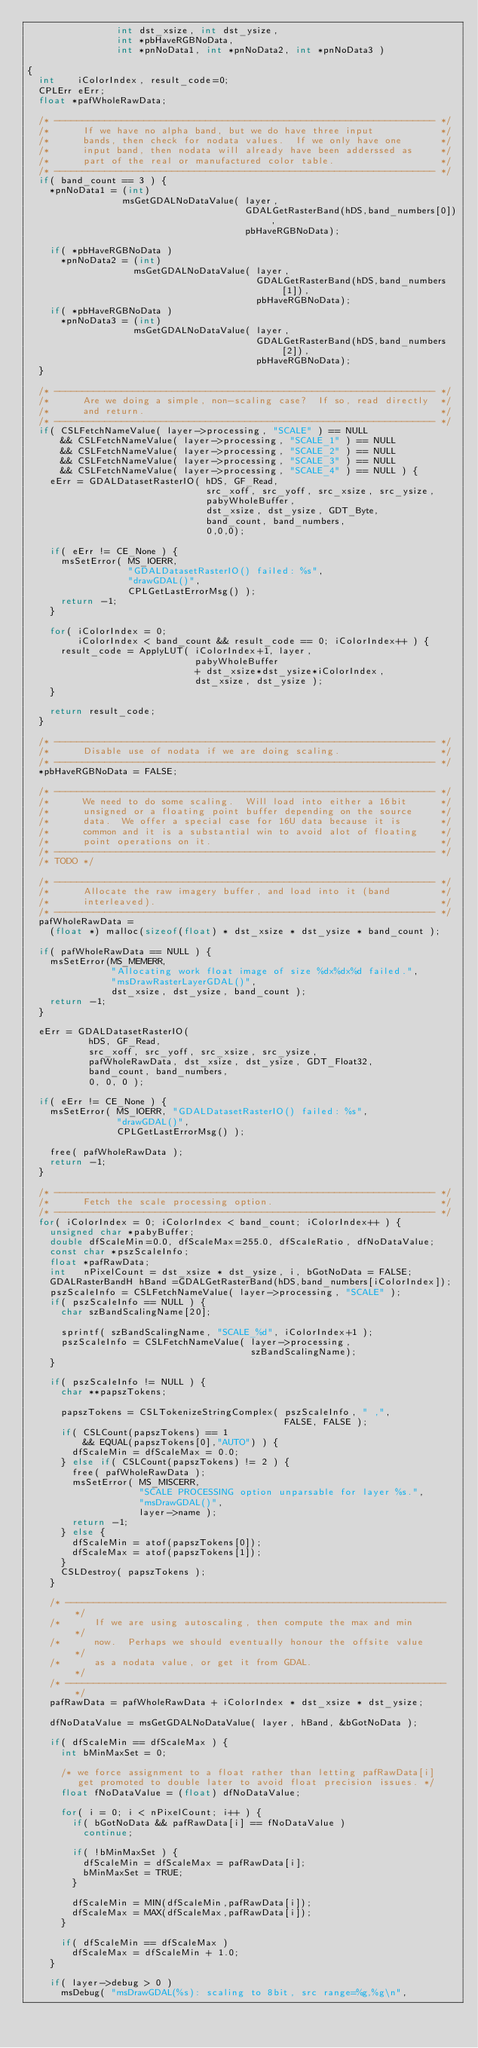Convert code to text. <code><loc_0><loc_0><loc_500><loc_500><_C_>                int dst_xsize, int dst_ysize,
                int *pbHaveRGBNoData,
                int *pnNoData1, int *pnNoData2, int *pnNoData3 )

{
  int    iColorIndex, result_code=0;
  CPLErr eErr;
  float *pafWholeRawData;

  /* -------------------------------------------------------------------- */
  /*      If we have no alpha band, but we do have three input            */
  /*      bands, then check for nodata values.  If we only have one       */
  /*      input band, then nodata will already have been adderssed as     */
  /*      part of the real or manufactured color table.                   */
  /* -------------------------------------------------------------------- */
  if( band_count == 3 ) {
    *pnNoData1 = (int)
                 msGetGDALNoDataValue( layer,
                                       GDALGetRasterBand(hDS,band_numbers[0]),
                                       pbHaveRGBNoData);

    if( *pbHaveRGBNoData )
      *pnNoData2 = (int)
                   msGetGDALNoDataValue( layer,
                                         GDALGetRasterBand(hDS,band_numbers[1]),
                                         pbHaveRGBNoData);
    if( *pbHaveRGBNoData )
      *pnNoData3 = (int)
                   msGetGDALNoDataValue( layer,
                                         GDALGetRasterBand(hDS,band_numbers[2]),
                                         pbHaveRGBNoData);
  }

  /* -------------------------------------------------------------------- */
  /*      Are we doing a simple, non-scaling case?  If so, read directly  */
  /*      and return.                                                     */
  /* -------------------------------------------------------------------- */
  if( CSLFetchNameValue( layer->processing, "SCALE" ) == NULL
      && CSLFetchNameValue( layer->processing, "SCALE_1" ) == NULL
      && CSLFetchNameValue( layer->processing, "SCALE_2" ) == NULL
      && CSLFetchNameValue( layer->processing, "SCALE_3" ) == NULL
      && CSLFetchNameValue( layer->processing, "SCALE_4" ) == NULL ) {
    eErr = GDALDatasetRasterIO( hDS, GF_Read,
                                src_xoff, src_yoff, src_xsize, src_ysize,
                                pabyWholeBuffer,
                                dst_xsize, dst_ysize, GDT_Byte,
                                band_count, band_numbers,
                                0,0,0);

    if( eErr != CE_None ) {
      msSetError( MS_IOERR,
                  "GDALDatasetRasterIO() failed: %s",
                  "drawGDAL()",
                  CPLGetLastErrorMsg() );
      return -1;
    }

    for( iColorIndex = 0;
         iColorIndex < band_count && result_code == 0; iColorIndex++ ) {
      result_code = ApplyLUT( iColorIndex+1, layer,
                              pabyWholeBuffer
                              + dst_xsize*dst_ysize*iColorIndex,
                              dst_xsize, dst_ysize );
    }

    return result_code;
  }

  /* -------------------------------------------------------------------- */
  /*      Disable use of nodata if we are doing scaling.                  */
  /* -------------------------------------------------------------------- */
  *pbHaveRGBNoData = FALSE;

  /* -------------------------------------------------------------------- */
  /*      We need to do some scaling.  Will load into either a 16bit      */
  /*      unsigned or a floating point buffer depending on the source     */
  /*      data.  We offer a special case for 16U data because it is       */
  /*      common and it is a substantial win to avoid alot of floating    */
  /*      point operations on it.                                         */
  /* -------------------------------------------------------------------- */
  /* TODO */

  /* -------------------------------------------------------------------- */
  /*      Allocate the raw imagery buffer, and load into it (band         */
  /*      interleaved).                                                   */
  /* -------------------------------------------------------------------- */
  pafWholeRawData =
    (float *) malloc(sizeof(float) * dst_xsize * dst_ysize * band_count );

  if( pafWholeRawData == NULL ) {
    msSetError(MS_MEMERR,
               "Allocating work float image of size %dx%dx%d failed.",
               "msDrawRasterLayerGDAL()",
               dst_xsize, dst_ysize, band_count );
    return -1;
  }

  eErr = GDALDatasetRasterIO(
           hDS, GF_Read,
           src_xoff, src_yoff, src_xsize, src_ysize,
           pafWholeRawData, dst_xsize, dst_ysize, GDT_Float32,
           band_count, band_numbers,
           0, 0, 0 );

  if( eErr != CE_None ) {
    msSetError( MS_IOERR, "GDALDatasetRasterIO() failed: %s",
                "drawGDAL()",
                CPLGetLastErrorMsg() );

    free( pafWholeRawData );
    return -1;
  }

  /* -------------------------------------------------------------------- */
  /*      Fetch the scale processing option.                              */
  /* -------------------------------------------------------------------- */
  for( iColorIndex = 0; iColorIndex < band_count; iColorIndex++ ) {
    unsigned char *pabyBuffer;
    double dfScaleMin=0.0, dfScaleMax=255.0, dfScaleRatio, dfNoDataValue;
    const char *pszScaleInfo;
    float *pafRawData;
    int   nPixelCount = dst_xsize * dst_ysize, i, bGotNoData = FALSE;
    GDALRasterBandH hBand =GDALGetRasterBand(hDS,band_numbers[iColorIndex]);
    pszScaleInfo = CSLFetchNameValue( layer->processing, "SCALE" );
    if( pszScaleInfo == NULL ) {
      char szBandScalingName[20];

      sprintf( szBandScalingName, "SCALE_%d", iColorIndex+1 );
      pszScaleInfo = CSLFetchNameValue( layer->processing,
                                        szBandScalingName);
    }

    if( pszScaleInfo != NULL ) {
      char **papszTokens;

      papszTokens = CSLTokenizeStringComplex( pszScaleInfo, " ,",
                                              FALSE, FALSE );
      if( CSLCount(papszTokens) == 1
          && EQUAL(papszTokens[0],"AUTO") ) {
        dfScaleMin = dfScaleMax = 0.0;
      } else if( CSLCount(papszTokens) != 2 ) {
        free( pafWholeRawData );
        msSetError( MS_MISCERR,
                    "SCALE PROCESSING option unparsable for layer %s.",
                    "msDrawGDAL()",
                    layer->name );
        return -1;
      } else {
        dfScaleMin = atof(papszTokens[0]);
        dfScaleMax = atof(papszTokens[1]);
      }
      CSLDestroy( papszTokens );
    }

    /* -------------------------------------------------------------------- */
    /*      If we are using autoscaling, then compute the max and min       */
    /*      now.  Perhaps we should eventually honour the offsite value     */
    /*      as a nodata value, or get it from GDAL.                         */
    /* -------------------------------------------------------------------- */
    pafRawData = pafWholeRawData + iColorIndex * dst_xsize * dst_ysize;

    dfNoDataValue = msGetGDALNoDataValue( layer, hBand, &bGotNoData );

    if( dfScaleMin == dfScaleMax ) {
      int bMinMaxSet = 0;

      /* we force assignment to a float rather than letting pafRawData[i]
         get promoted to double later to avoid float precision issues. */
      float fNoDataValue = (float) dfNoDataValue;

      for( i = 0; i < nPixelCount; i++ ) {
        if( bGotNoData && pafRawData[i] == fNoDataValue )
          continue;

        if( !bMinMaxSet ) {
          dfScaleMin = dfScaleMax = pafRawData[i];
          bMinMaxSet = TRUE;
        }

        dfScaleMin = MIN(dfScaleMin,pafRawData[i]);
        dfScaleMax = MAX(dfScaleMax,pafRawData[i]);
      }

      if( dfScaleMin == dfScaleMax )
        dfScaleMax = dfScaleMin + 1.0;
    }

    if( layer->debug > 0 )
      msDebug( "msDrawGDAL(%s): scaling to 8bit, src range=%g,%g\n",</code> 